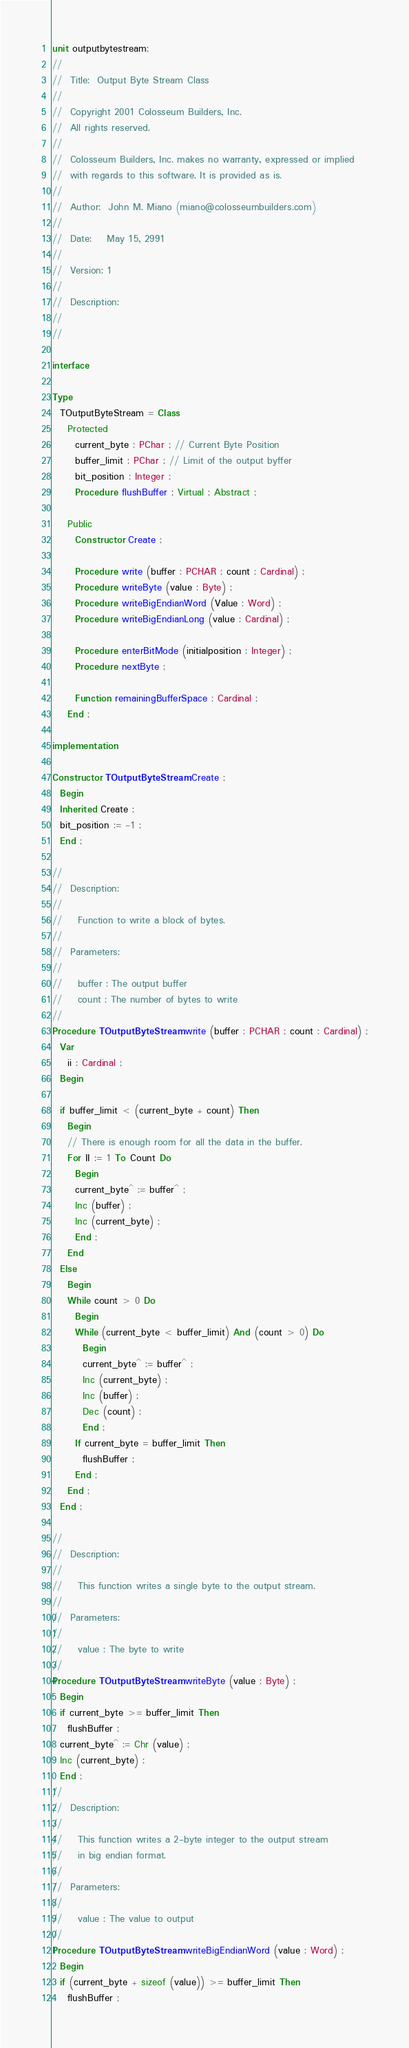Convert code to text. <code><loc_0><loc_0><loc_500><loc_500><_Pascal_>unit outputbytestream;
//
//  Title:  Output Byte Stream Class
//
//  Copyright 2001 Colosseum Builders, Inc.
//  All rights reserved.
//
//  Colosseum Builders, Inc. makes no warranty, expressed or implied
//  with regards to this software. It is provided as is.
//
//  Author:  John M. Miano (miano@colosseumbuilders.com)
//
//  Date:    May 15, 2991
//
//  Version: 1
//
//  Description:
//
//

interface

Type
  TOutputByteStream = Class
    Protected
      current_byte : PChar ; // Current Byte Position
      buffer_limit : PChar ; // Limit of the output byffer
      bit_position : Integer ;
      Procedure flushBuffer ; Virtual ; Abstract ;

    Public
      Constructor Create ;

      Procedure write (buffer : PCHAR ; count : Cardinal) ;
      Procedure writeByte (value : Byte) ;
      Procedure writeBigEndianWord (Value : Word) ;
      Procedure writeBigEndianLong (value : Cardinal) ;

      Procedure enterBitMode (initialposition : Integer) ;
      Procedure nextByte ;

      Function remainingBufferSpace : Cardinal ;
    End ;

implementation

Constructor TOutputByteStream.Create ;
  Begin
  Inherited Create ;
  bit_position := -1 ;
  End ;

//
//  Description:
//
//    Function to write a block of bytes.
//
//  Parameters:
//
//    buffer : The output buffer
//    count : The number of bytes to write
//
Procedure TOutputByteStream.write (buffer : PCHAR ; count : Cardinal) ;
  Var
    ii : Cardinal ;
  Begin

  if buffer_limit < (current_byte + count) Then
    Begin
    // There is enough room for all the data in the buffer.
    For II := 1 To Count Do
      Begin
      current_byte^ := buffer^ ;
      Inc (buffer) ;
      Inc (current_byte) ;
      End ;
    End
  Else
    Begin
    While count > 0 Do
      Begin
      While (current_byte < buffer_limit) And (count > 0) Do
        Begin
        current_byte^ := buffer^ ;
        Inc (current_byte) ;
        Inc (buffer) ;
        Dec (count) ;
        End ;
      If current_byte = buffer_limit Then
        flushBuffer ;
      End ;
    End ;
  End ;

//
//  Description:
//
//    This function writes a single byte to the output stream.
//
//  Parameters:
//
//    value : The byte to write
//
Procedure TOutputByteStream.writeByte (value : Byte) ;
  Begin
  if current_byte >= buffer_limit Then
    flushBuffer ;
  current_byte^ := Chr (value) ;
  Inc (current_byte) ;
  End ;
//
//  Description:
//
//    This function writes a 2-byte integer to the output stream
//    in big endian format.
//
//  Parameters:
//
//    value : The value to output
//
Procedure TOutputByteStream.writeBigEndianWord (value : Word) ;
  Begin
  if (current_byte + sizeof (value)) >= buffer_limit Then
    flushBuffer ;
</code> 